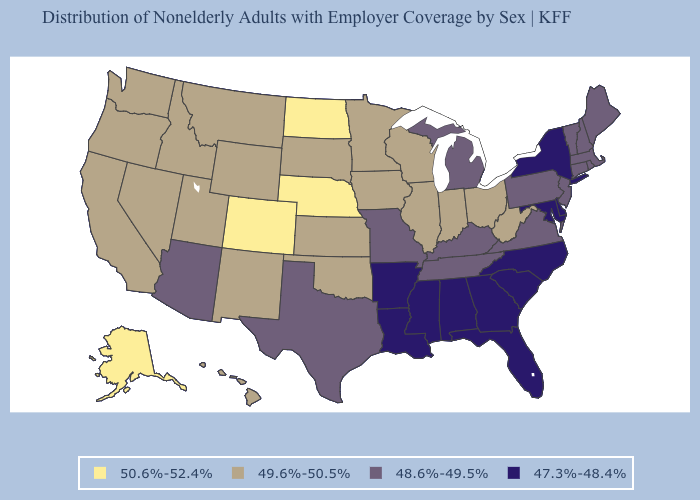What is the value of Arkansas?
Write a very short answer. 47.3%-48.4%. What is the highest value in the USA?
Concise answer only. 50.6%-52.4%. Which states have the lowest value in the USA?
Give a very brief answer. Alabama, Arkansas, Delaware, Florida, Georgia, Louisiana, Maryland, Mississippi, New York, North Carolina, South Carolina. Does Massachusetts have a lower value than Wisconsin?
Write a very short answer. Yes. Does North Dakota have the highest value in the MidWest?
Be succinct. Yes. Does Wisconsin have the lowest value in the USA?
Quick response, please. No. How many symbols are there in the legend?
Short answer required. 4. What is the lowest value in states that border Virginia?
Be succinct. 47.3%-48.4%. Does the first symbol in the legend represent the smallest category?
Concise answer only. No. Which states have the lowest value in the USA?
Be succinct. Alabama, Arkansas, Delaware, Florida, Georgia, Louisiana, Maryland, Mississippi, New York, North Carolina, South Carolina. What is the value of Illinois?
Give a very brief answer. 49.6%-50.5%. Name the states that have a value in the range 47.3%-48.4%?
Answer briefly. Alabama, Arkansas, Delaware, Florida, Georgia, Louisiana, Maryland, Mississippi, New York, North Carolina, South Carolina. Does the first symbol in the legend represent the smallest category?
Concise answer only. No. Name the states that have a value in the range 48.6%-49.5%?
Write a very short answer. Arizona, Connecticut, Kentucky, Maine, Massachusetts, Michigan, Missouri, New Hampshire, New Jersey, Pennsylvania, Rhode Island, Tennessee, Texas, Vermont, Virginia. 